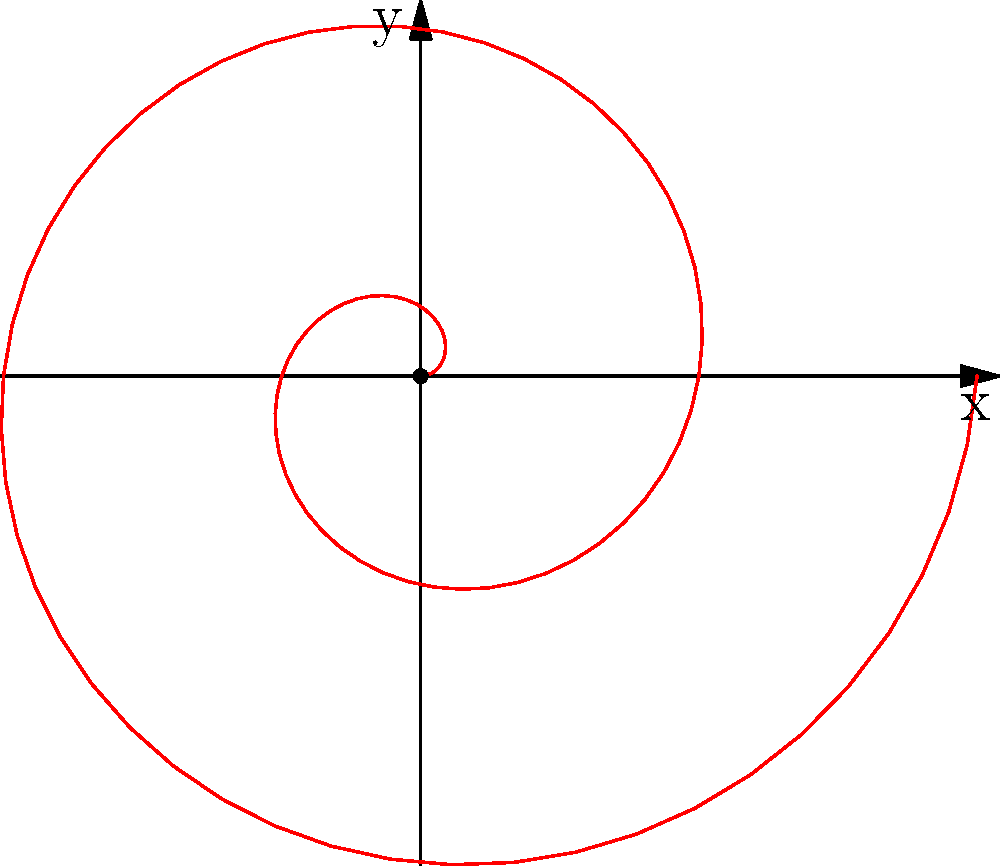Consider the polar equation $r = 0.2\theta$. What type of spiral does this equation represent, and how many complete revolutions are shown in the graph? To answer this question, let's break it down step-by-step:

1. Identify the type of spiral:
   The polar equation $r = 0.2\theta$ is in the form $r = a\theta$, where $a$ is a constant (in this case, $a = 0.2$). This form represents an Archimedean spiral.

2. Characteristics of an Archimedean spiral:
   - The distance between successive turnings is constant.
   - The spiral expands outward at a constant rate as $\theta$ increases.

3. Count the revolutions:
   - One complete revolution corresponds to an angle of $2\pi$ radians.
   - In the graph, we can see that the spiral makes two complete turns.

4. Verify the number of revolutions:
   - The graph shows the spiral from $\theta = 0$ to $\theta = 4\pi$.
   - This range of $\theta$ confirms that there are indeed two complete revolutions $(4\pi / 2\pi = 2)$.

Therefore, the graph shows an Archimedean spiral with two complete revolutions.
Answer: Archimedean spiral; 2 revolutions 